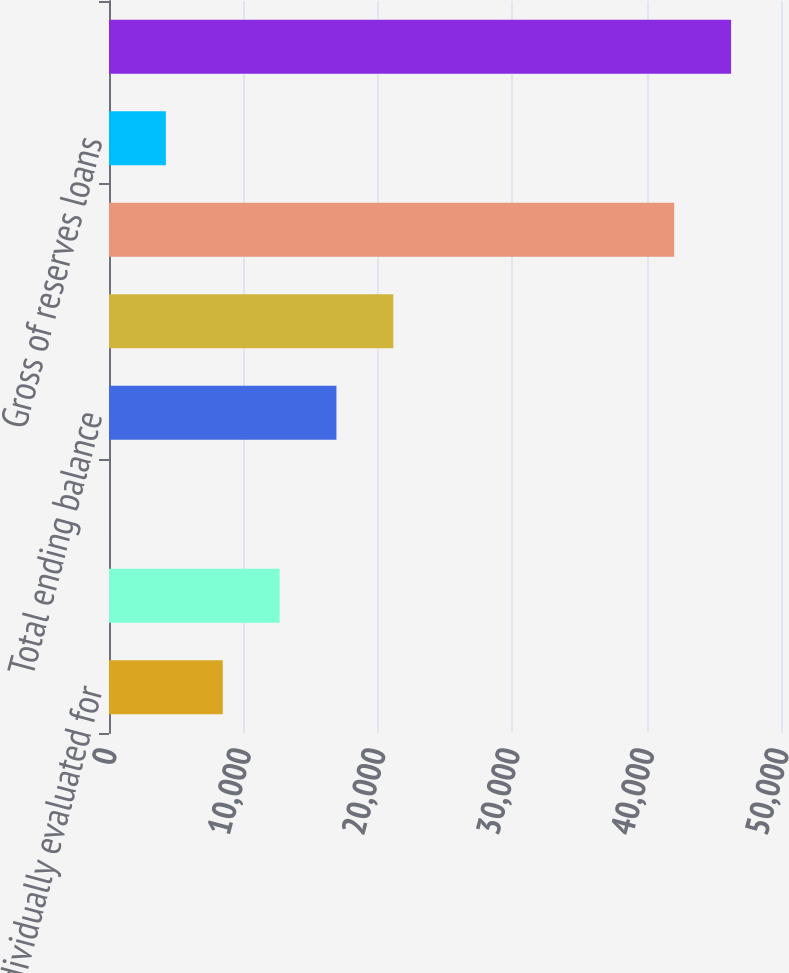Convert chart. <chart><loc_0><loc_0><loc_500><loc_500><bar_chart><fcel>Individually evaluated for<fcel>Collectively evaluated for<fcel>Loans acquired with<fcel>Total ending balance<fcel>Gross of reserves individually<fcel>Gross of reserves collectively<fcel>Gross of reserves loans<fcel>Total ending balance gross of<nl><fcel>8462.1<fcel>12692.2<fcel>1.88<fcel>16922.3<fcel>21152.4<fcel>42056<fcel>4231.99<fcel>46286.1<nl></chart> 